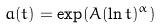Convert formula to latex. <formula><loc_0><loc_0><loc_500><loc_500>a ( t ) = \exp ( A ( \ln t ) ^ { \alpha } )</formula> 